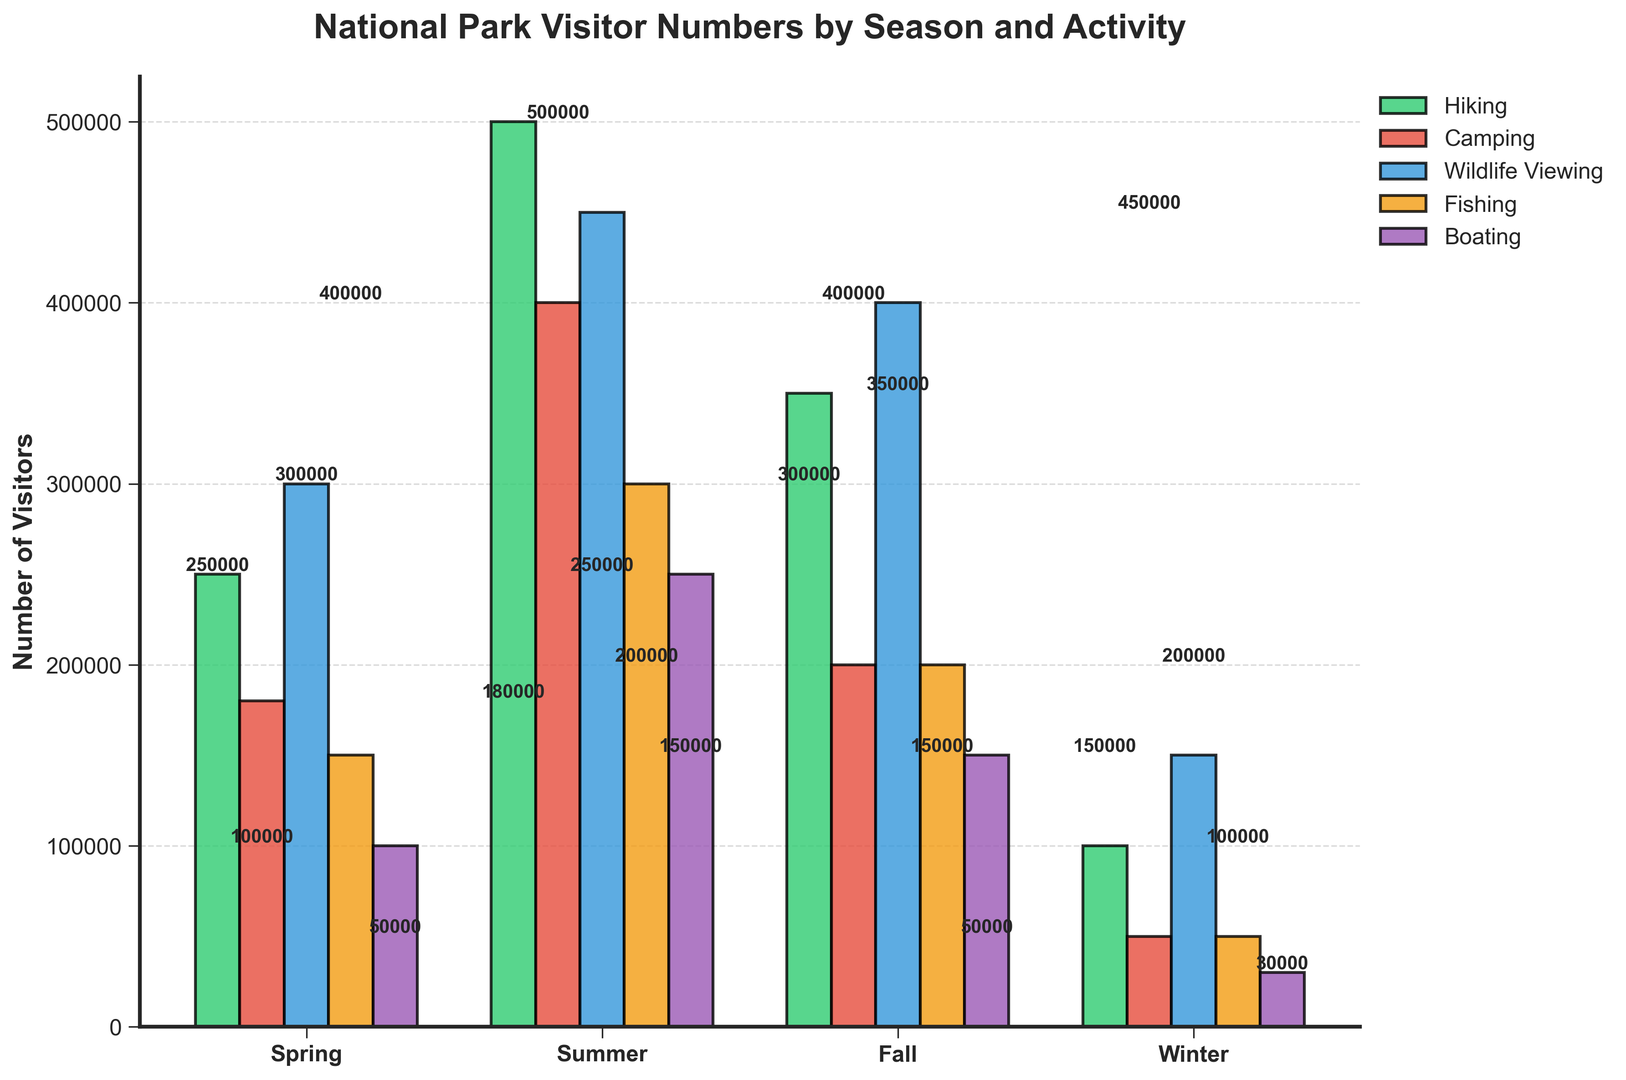What's the total number of visitors for hiking across all seasons? To find the total number of visitors for hiking across all seasons, add up the visitors for each season: Spring (250,000) + Summer (500,000) + Fall (350,000) + Winter (100,000).
Answer: 1,200,000 Which season has the highest number of visitors for wildlife viewing? Compare the number of visitors for wildlife viewing in each season: Spring (300,000), Summer (450,000), Fall (400,000), Winter (150,000). The highest value is in Summer.
Answer: Summer In which season did camping have fewer visitors than fishing? Compare the number of visitors for camping and fishing in each season: Spring (180,000 vs. 150,000), Summer (400,000 vs. 300,000), Fall (200,000 vs. 200,000), Winter (50,000 vs. 50,000). Only Spring has camping visitors (180,000) greater than fishing visitors (150,000); other seasons have fewer or equal visitors for camping compared to fishing.
Answer: None What is the combined number of visitors for boating in Spring and Fall? Add the number of visitors for boating in Spring (100,000) and Fall (150,000): 100,000 + 150,000 = 250,000.
Answer: 250,000 Which recreational activity had the lowest number of visitors in winter? Compare the number of visitors for each recreational activity in Winter: Hiking (100,000), Camping (50,000), Wildlife Viewing (150,000), Fishing (50,000), Boating (30,000). The lowest value is for Boating.
Answer: Boating How many more visitors went hiking in Summer compared to Spring? Subtract the number of visitors for hiking in Spring (250,000) from Summer (500,000): 500,000 - 250,000.
Answer: 250,000 By how much did the number of visitors for wildlife viewing decrease from Summer to Fall? Subtract the number of visitors for wildlife viewing in Fall (400,000) from Summer (450,000): 450,000 - 400,000.
Answer: 50,000 Which two seasons combined see the highest number of visitors for camping? Add the visitors for camping across pairs of seasons: Spring & Summer (180,000 + 400,000 = 580,000), Spring & Fall (180,000 + 200,000 = 380,000), Spring & Winter (180,000 + 50,000 = 230,000), Summer & Fall (400,000 + 200,000 = 600,000), Summer & Winter (400,000 + 50,000 = 450,000), Fall & Winter (200,000 + 50,000 = 250,000). The highest combination is Summer & Fall with 600,000.
Answer: Summer & Fall 